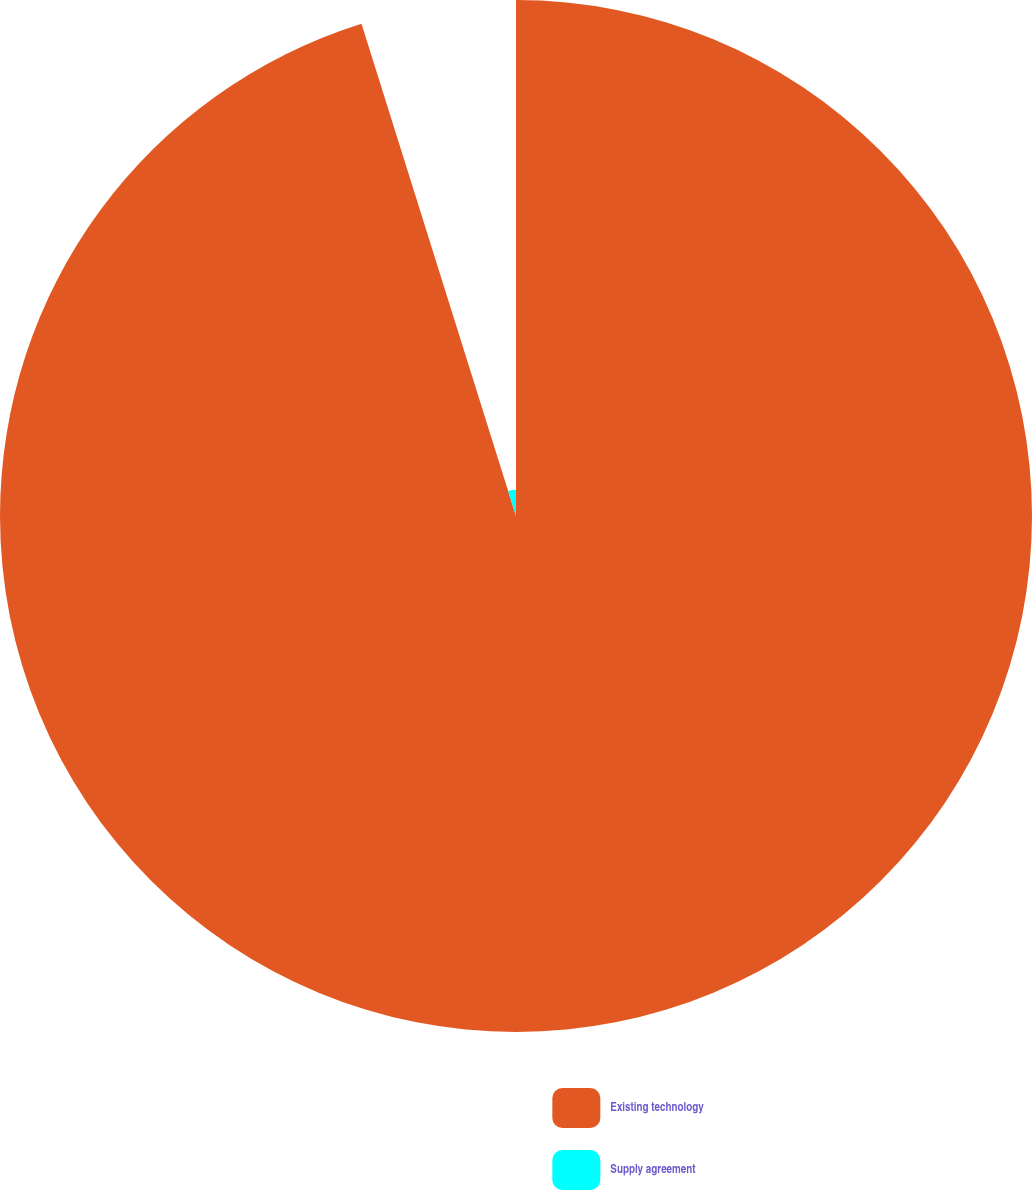Convert chart to OTSL. <chart><loc_0><loc_0><loc_500><loc_500><pie_chart><fcel>Existing technology<fcel>Supply agreement<nl><fcel>95.16%<fcel>4.84%<nl></chart> 